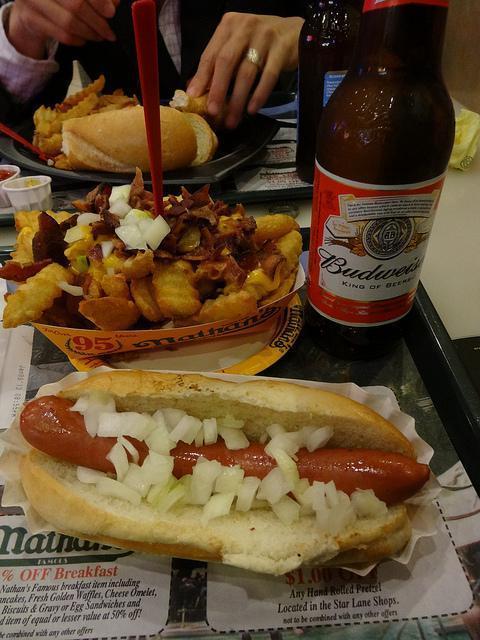Is this affirmation: "The person is surrounding the hot dog." correct?
Answer yes or no. No. Is "The person is touching the hot dog." an appropriate description for the image?
Answer yes or no. No. 